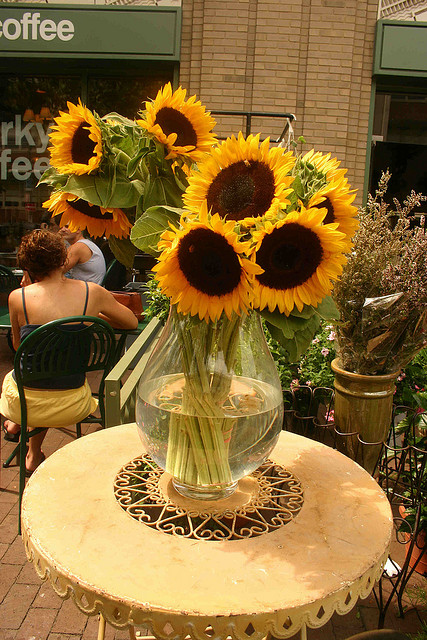Extract all visible text content from this image. Coffee rky 